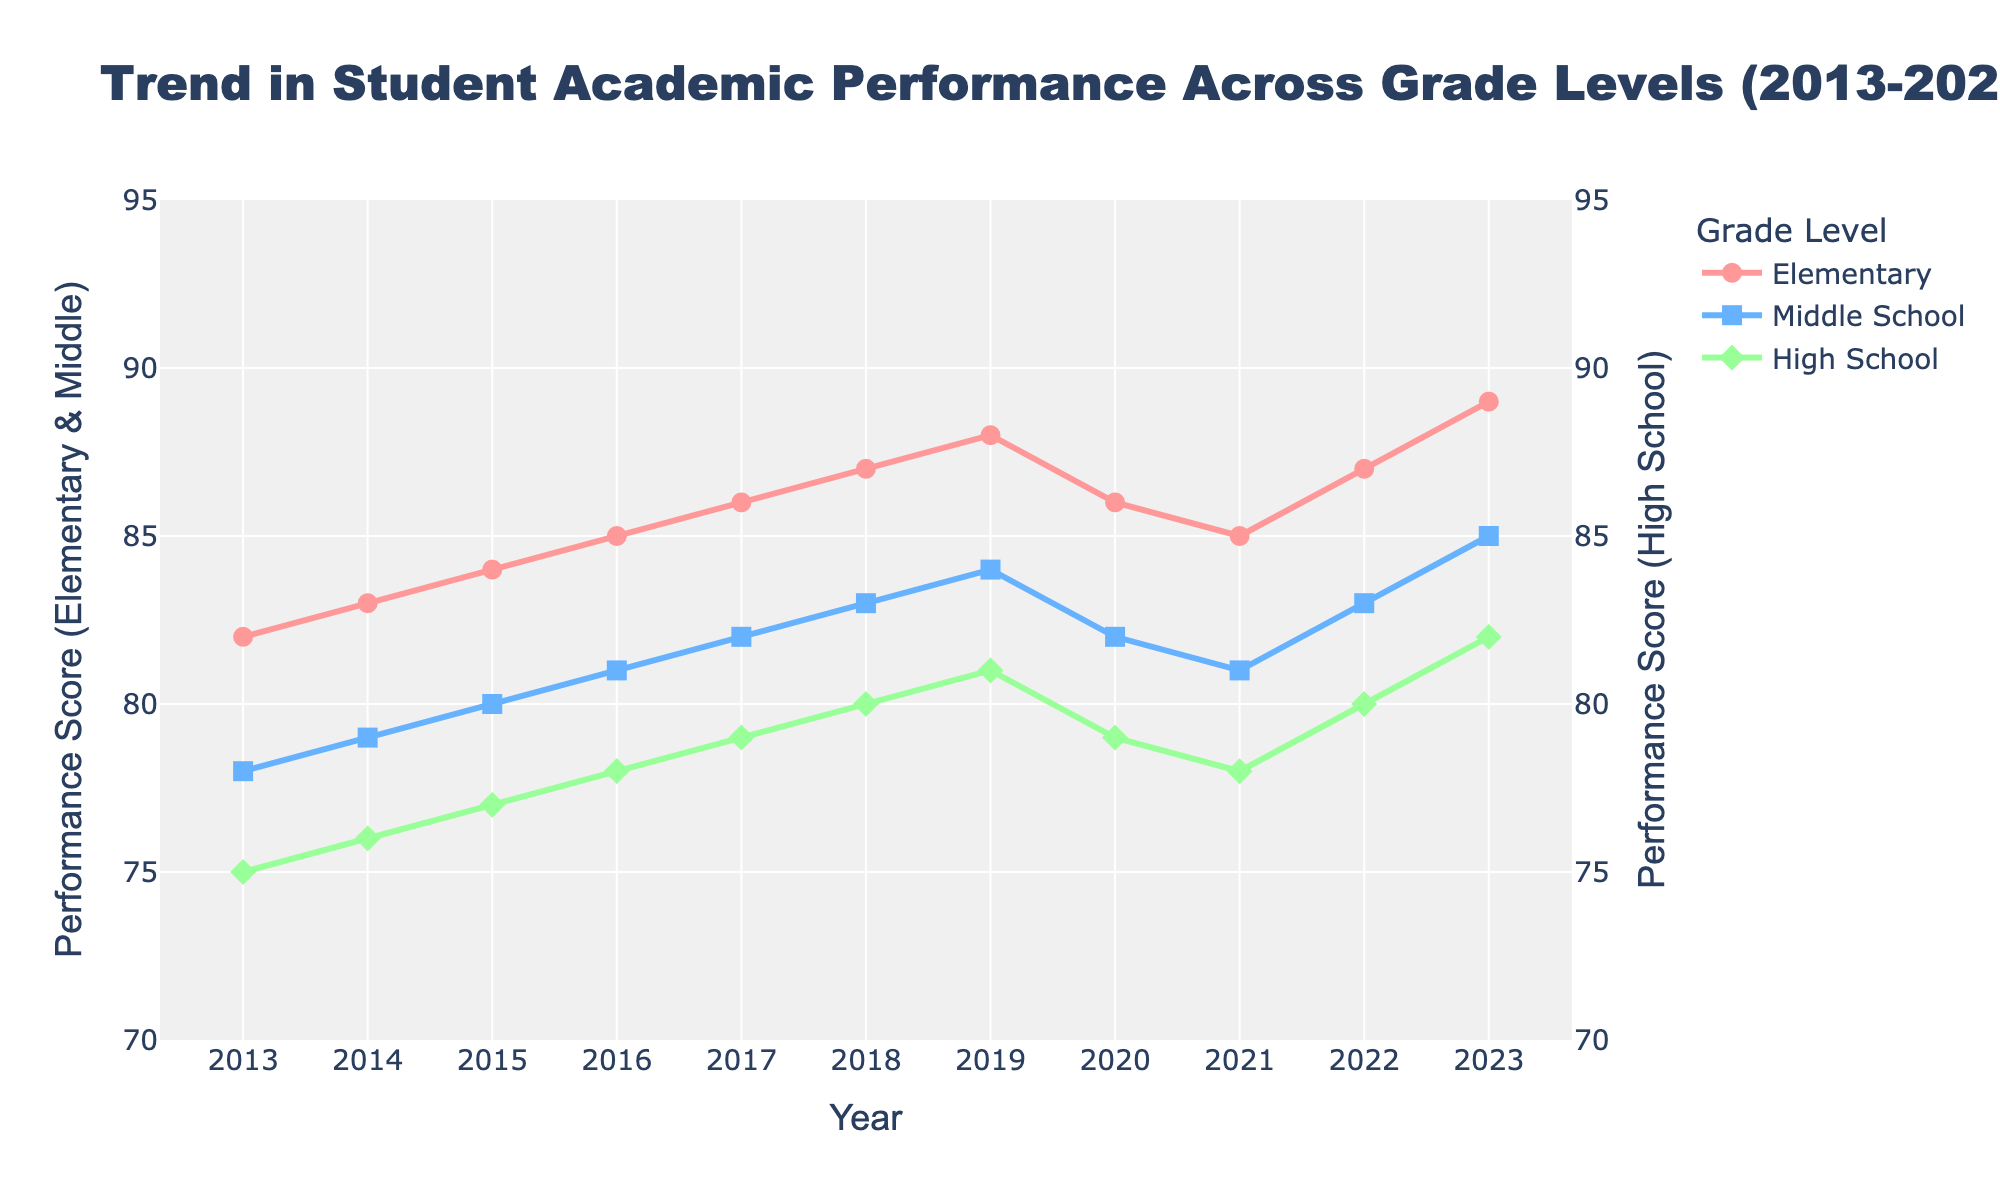What is the trend in Elementary school performance from 2013 to 2023? To identify the trend, observe the line representing Elementary school performance on the graph from 2013 to 2023. The line shows an upward trajectory, meaning performance scores have generally increased over this period.
Answer: Increasing In which year did Middle School performance peak and what was the score? Look for the highest point on the Middle School line. The peak occurs in 2023 with a score of 85.
Answer: 2023, 85 Which grade level had the lowest performance score in 2021 and what was the score? Compare the points for the year 2021 across all three grade levels: Elementary, Middle School, and High School. High School had the lowest score in 2021 with a performance score of 78.
Answer: High School, 78 Did High School performance ever surpass Middle School performance from 2013 to 2023? Observe the line trends for High School and Middle School. The High School line is consistently below the Middle School line, indicating that High School performance never surpassed Middle School performance within this period.
Answer: No Calculate the average performance score for Elementary, Middle School, and High School in 2018. Add up the scores for each grade level in 2018: Elementary (87), Middle School (83), and High School (80). The total is 87 + 83 + 80 = 250. Divide by 3 to find the average: 250 / 3 ≈ 83.33.
Answer: 83.33 Which grade level saw the most significant decline in performance from 2019 to 2020? Compare the performance scores from 2019 to 2020 for each grade level: Elementary (88 to 86), Middle School (84 to 82), and High School (81 to 79). Each grade level declined by 2 points, so the decline is consistent across all grade levels.
Answer: All grades declined equally What is the color associated with the Middle School performance line? Observe the color of the line that represents Middle School performance. The middle school line is blue.
Answer: Blue By how many points did Elementary school performance improve from 2013 to 2023? Subtract the performance score for Elementary school in 2013 (82) from the score in 2023 (89). The difference is 89 - 82 = 7 points.
Answer: 7 points Compare the Elementary and High School performance trends from 2016 to 2017. Which had a greater increase and by how much? Check the scores for Elementary (85 to 86) and High School (78 to 79) from 2016 to 2017. Elementary increased by 1 point (86 - 85 = 1) and High School also increased by 1 point (79 - 78 = 1). Both increased equally.
Answer: Both increased equally by 1 point 